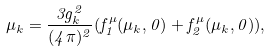Convert formula to latex. <formula><loc_0><loc_0><loc_500><loc_500>\mu _ { k } = \frac { 3 g _ { k } ^ { 2 } } { ( 4 \pi ) ^ { 2 } } ( f _ { 1 } ^ { \mu } ( \mu _ { k } , 0 ) + f _ { 2 } ^ { \mu } ( \mu _ { k } , 0 ) ) ,</formula> 